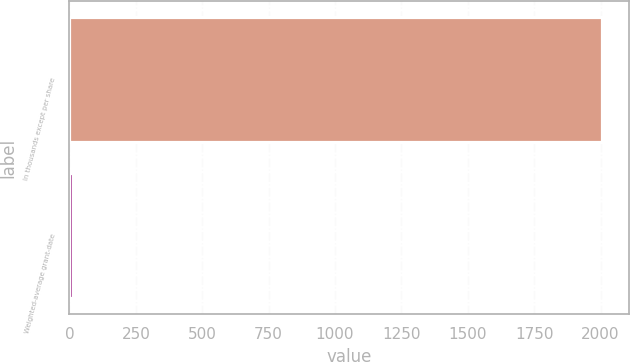Convert chart. <chart><loc_0><loc_0><loc_500><loc_500><bar_chart><fcel>In thousands except per share<fcel>Weighted-average grant-date<nl><fcel>2007<fcel>11.65<nl></chart> 